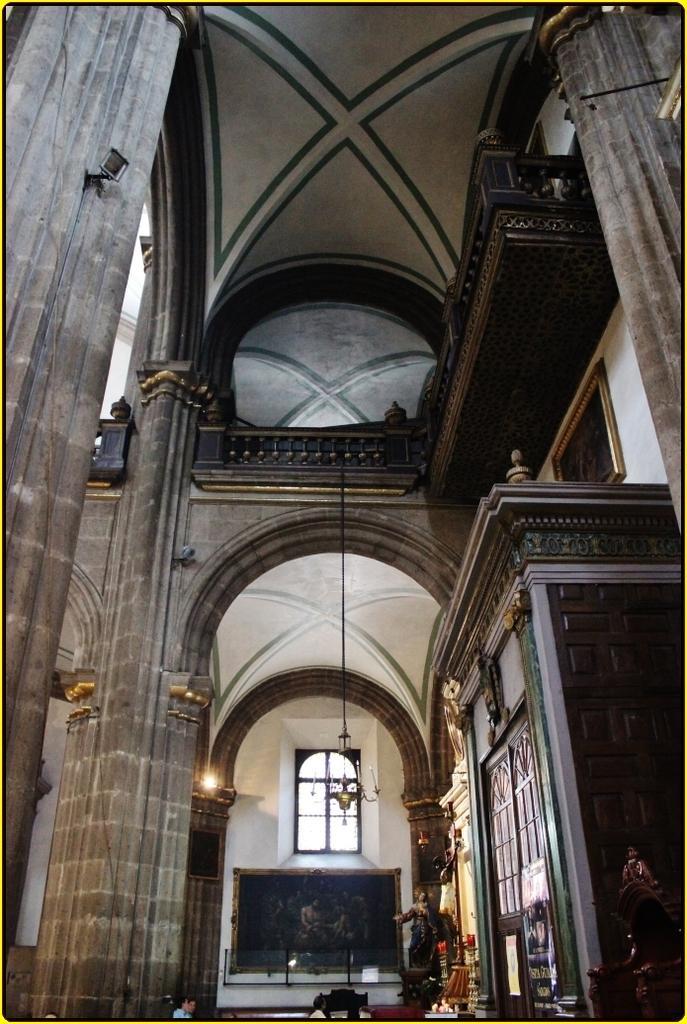Can you describe this image briefly? This is the picture inside of the building. At the right there is a cupboard. At the back there is a photo frame on the wall and there is a window at the top. There are statuettes at the bottom and at the left there is a light. At the bottom there are people. At the left there is a light and at the left there is a pillar. 